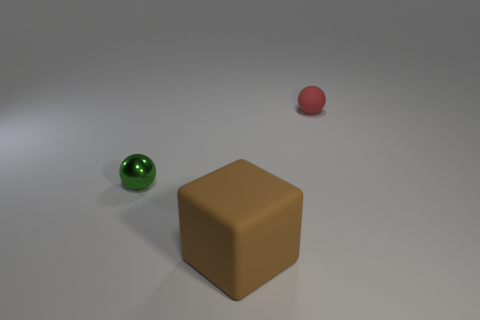Is there any indication of where these objects could be located? There is no definitive indication of location as the background is nondescript. However, the clean and controlled lighting suggests this could be a setting like a studio or a controlled indoor environment where objects are typically placed for observation or photography. 